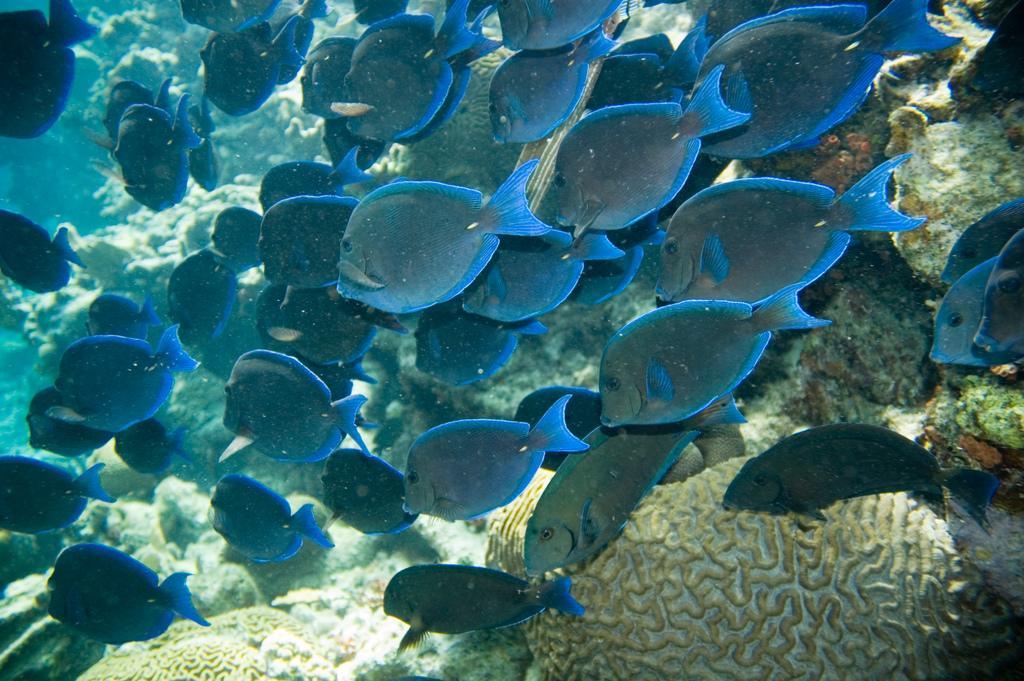In one or two sentences, can you explain what this image depicts? In this image we can see group of fishes which are called as Atlantic blue tang are under water and there are some water plants. 